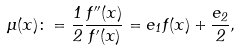Convert formula to latex. <formula><loc_0><loc_0><loc_500><loc_500>\mu ( x ) \colon = \frac { 1 } { 2 } \frac { f ^ { \prime \prime } ( x ) } { f ^ { \prime } ( x ) } = e _ { 1 } f ( x ) + \frac { e _ { 2 } } { 2 } ,</formula> 